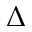Convert formula to latex. <formula><loc_0><loc_0><loc_500><loc_500>\Delta</formula> 